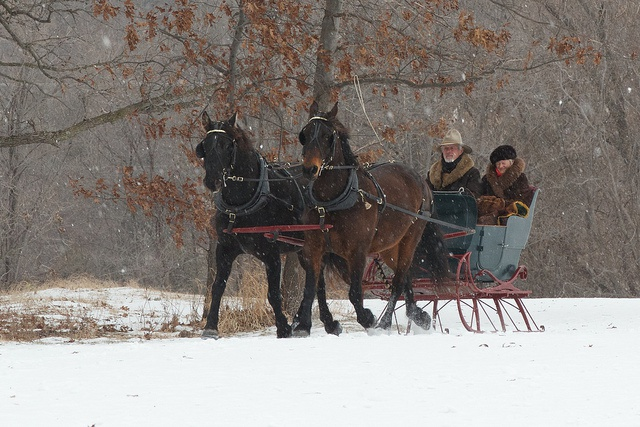Describe the objects in this image and their specific colors. I can see horse in black, gray, and maroon tones, horse in black, gray, maroon, and darkgray tones, people in black, gray, and maroon tones, and people in black and gray tones in this image. 